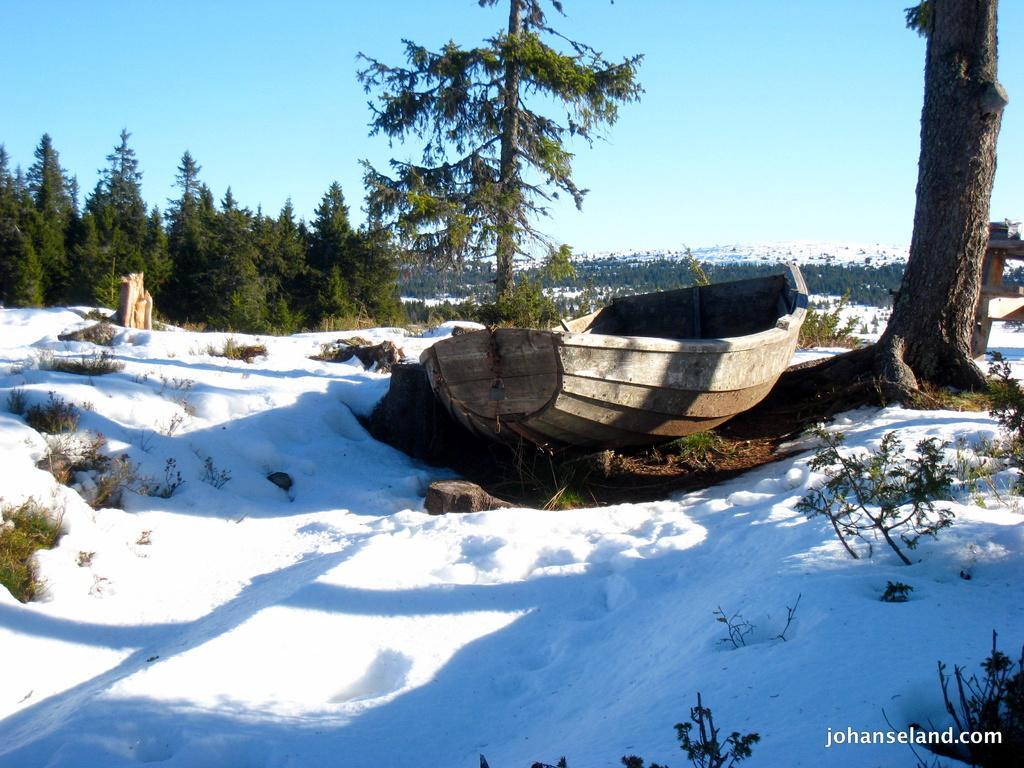Can you describe this image briefly? In the center of the image we can see a boat on the ground. In the background, we can see a group of trees, hills and the sky. At the bottom we can see some plants and some text. 